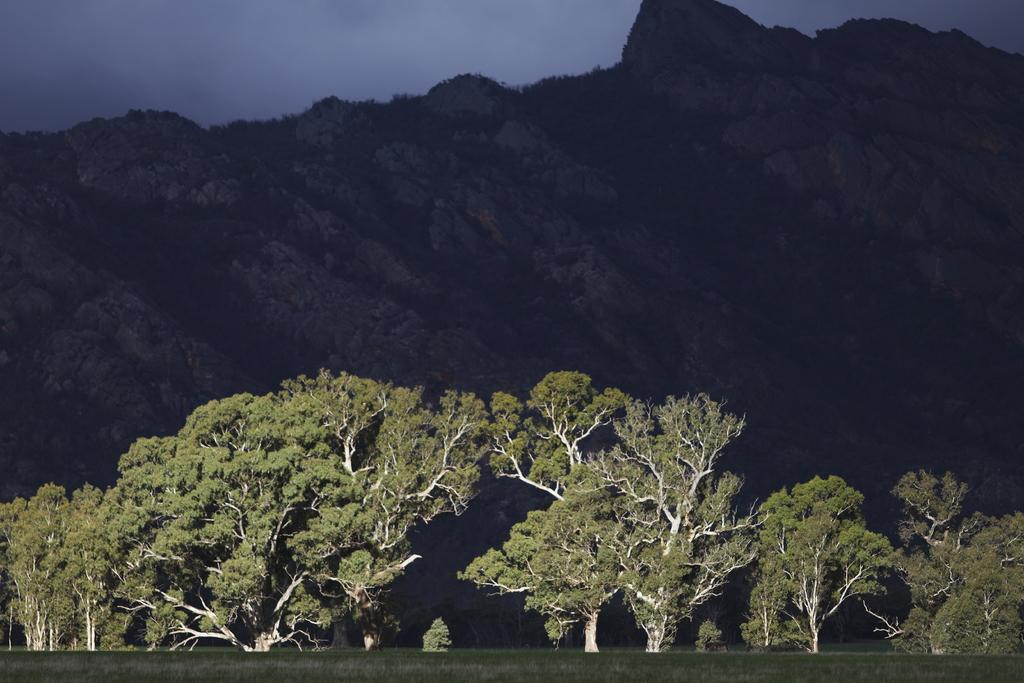What type of vegetation is visible in the front of the image? There are trees in the front of the image. What type of natural formation can be seen in the background of the image? There are mountains in the background of the image. How would you describe the sky in the image? The sky is cloudy in the image. Who is the owner of the plants in the image? There are no plants mentioned in the image, only trees. How can you measure the height of the clouds in the image? The image is a two-dimensional representation, so it is not possible to measure the height of the clouds in the image. 